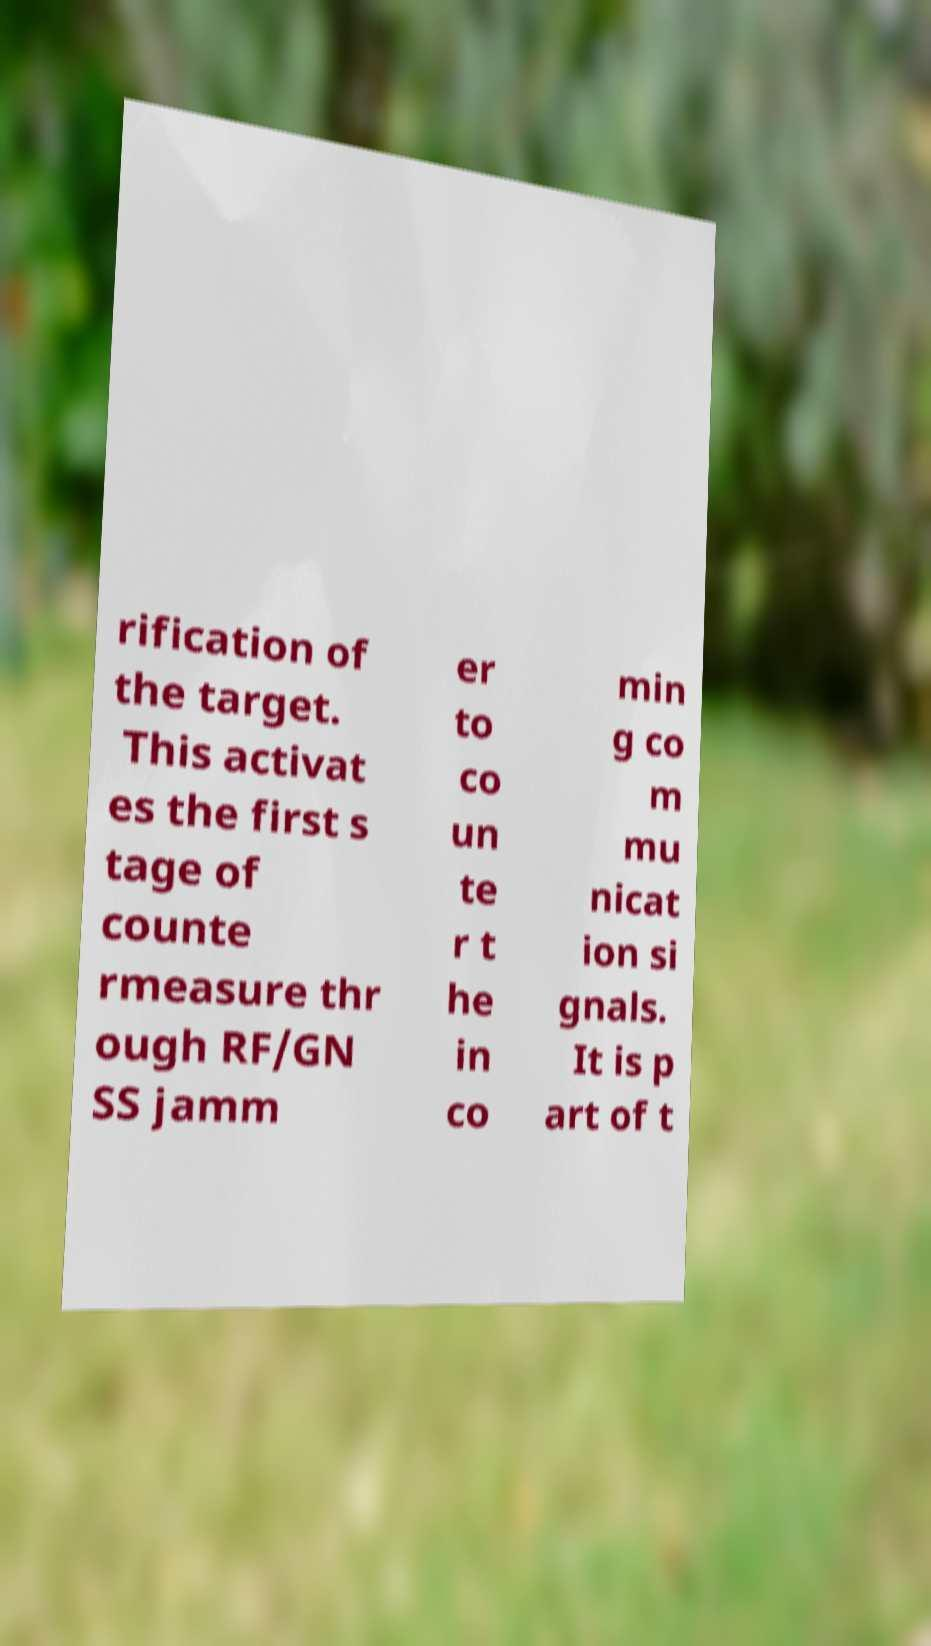I need the written content from this picture converted into text. Can you do that? rification of the target. This activat es the first s tage of counte rmeasure thr ough RF/GN SS jamm er to co un te r t he in co min g co m mu nicat ion si gnals. It is p art of t 